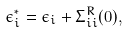<formula> <loc_0><loc_0><loc_500><loc_500>\epsilon _ { i } ^ { * } = \epsilon _ { i } + \Sigma _ { i i } ^ { R } ( 0 ) ,</formula> 